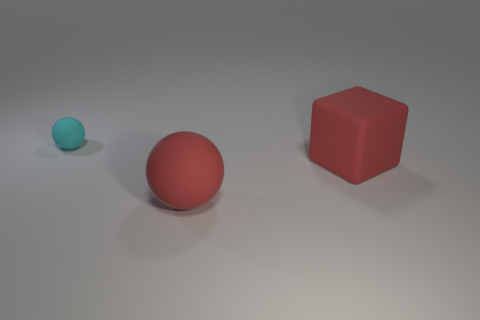Add 2 big cylinders. How many objects exist? 5 Subtract all cyan spheres. How many spheres are left? 1 Subtract 0 yellow cylinders. How many objects are left? 3 Subtract all cubes. How many objects are left? 2 Subtract 2 spheres. How many spheres are left? 0 Subtract all brown blocks. Subtract all brown cylinders. How many blocks are left? 1 Subtract all green cylinders. How many cyan blocks are left? 0 Subtract all large blue matte things. Subtract all red objects. How many objects are left? 1 Add 2 cyan balls. How many cyan balls are left? 3 Add 3 yellow balls. How many yellow balls exist? 3 